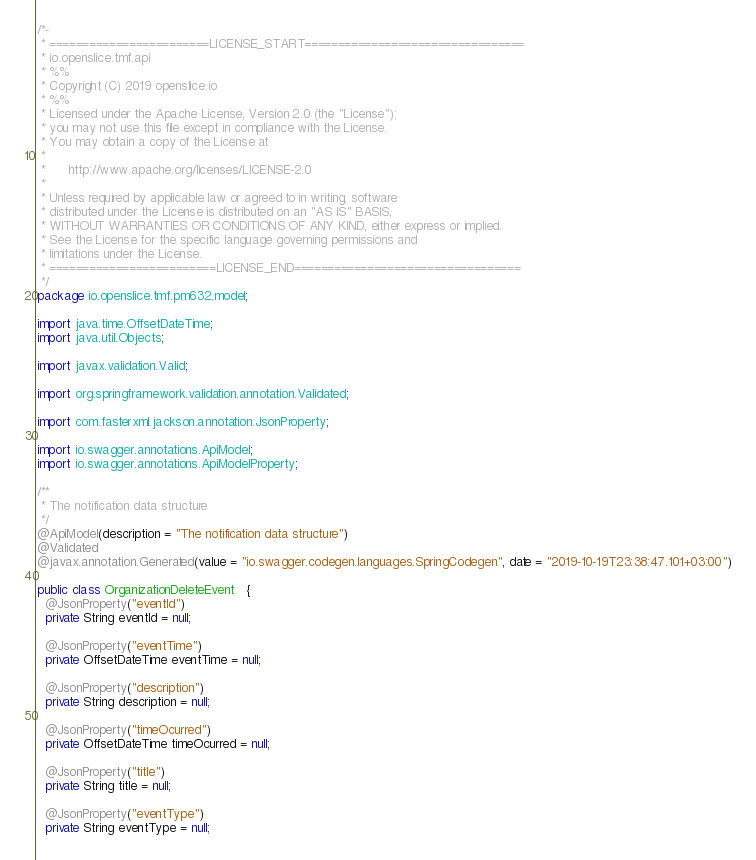<code> <loc_0><loc_0><loc_500><loc_500><_Java_>/*-
 * ========================LICENSE_START=================================
 * io.openslice.tmf.api
 * %%
 * Copyright (C) 2019 openslice.io
 * %%
 * Licensed under the Apache License, Version 2.0 (the "License");
 * you may not use this file except in compliance with the License.
 * You may obtain a copy of the License at
 * 
 *      http://www.apache.org/licenses/LICENSE-2.0
 * 
 * Unless required by applicable law or agreed to in writing, software
 * distributed under the License is distributed on an "AS IS" BASIS,
 * WITHOUT WARRANTIES OR CONDITIONS OF ANY KIND, either express or implied.
 * See the License for the specific language governing permissions and
 * limitations under the License.
 * =========================LICENSE_END==================================
 */
package io.openslice.tmf.pm632.model;

import java.time.OffsetDateTime;
import java.util.Objects;

import javax.validation.Valid;

import org.springframework.validation.annotation.Validated;

import com.fasterxml.jackson.annotation.JsonProperty;

import io.swagger.annotations.ApiModel;
import io.swagger.annotations.ApiModelProperty;

/**
 * The notification data structure
 */
@ApiModel(description = "The notification data structure")
@Validated
@javax.annotation.Generated(value = "io.swagger.codegen.languages.SpringCodegen", date = "2019-10-19T23:38:47.101+03:00")

public class OrganizationDeleteEvent   {
  @JsonProperty("eventId")
  private String eventId = null;

  @JsonProperty("eventTime")
  private OffsetDateTime eventTime = null;

  @JsonProperty("description")
  private String description = null;

  @JsonProperty("timeOcurred")
  private OffsetDateTime timeOcurred = null;

  @JsonProperty("title")
  private String title = null;

  @JsonProperty("eventType")
  private String eventType = null;
</code> 